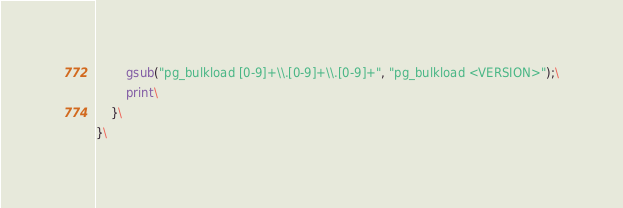<code> <loc_0><loc_0><loc_500><loc_500><_Awk_>		gsub("pg_bulkload [0-9]+\\.[0-9]+\\.[0-9]+", "pg_bulkload <VERSION>");\
		print\
	}\
}\
</code> 